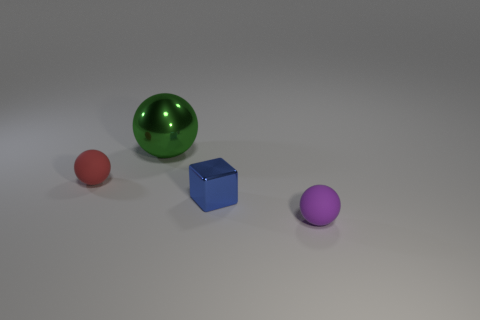Are there any other things that have the same size as the green ball?
Your answer should be very brief. No. What number of tiny cyan rubber objects are the same shape as the large thing?
Offer a very short reply. 0. What is the color of the ball behind the small ball that is behind the metal object that is in front of the tiny red sphere?
Give a very brief answer. Green. Do the thing that is behind the red rubber thing and the tiny sphere that is in front of the red object have the same material?
Provide a succinct answer. No. How many objects are rubber objects that are behind the tiny purple rubber object or small gray spheres?
Keep it short and to the point. 1. What number of things are big metallic objects or tiny matte things in front of the blue metallic block?
Provide a short and direct response. 2. How many blue metallic objects are the same size as the red object?
Your answer should be compact. 1. Is the number of big green metallic spheres to the left of the tiny red matte thing less than the number of green metallic things on the right side of the large metal sphere?
Ensure brevity in your answer.  No. What number of matte things are either tiny brown spheres or large balls?
Offer a terse response. 0. The large metal object has what shape?
Offer a terse response. Sphere. 